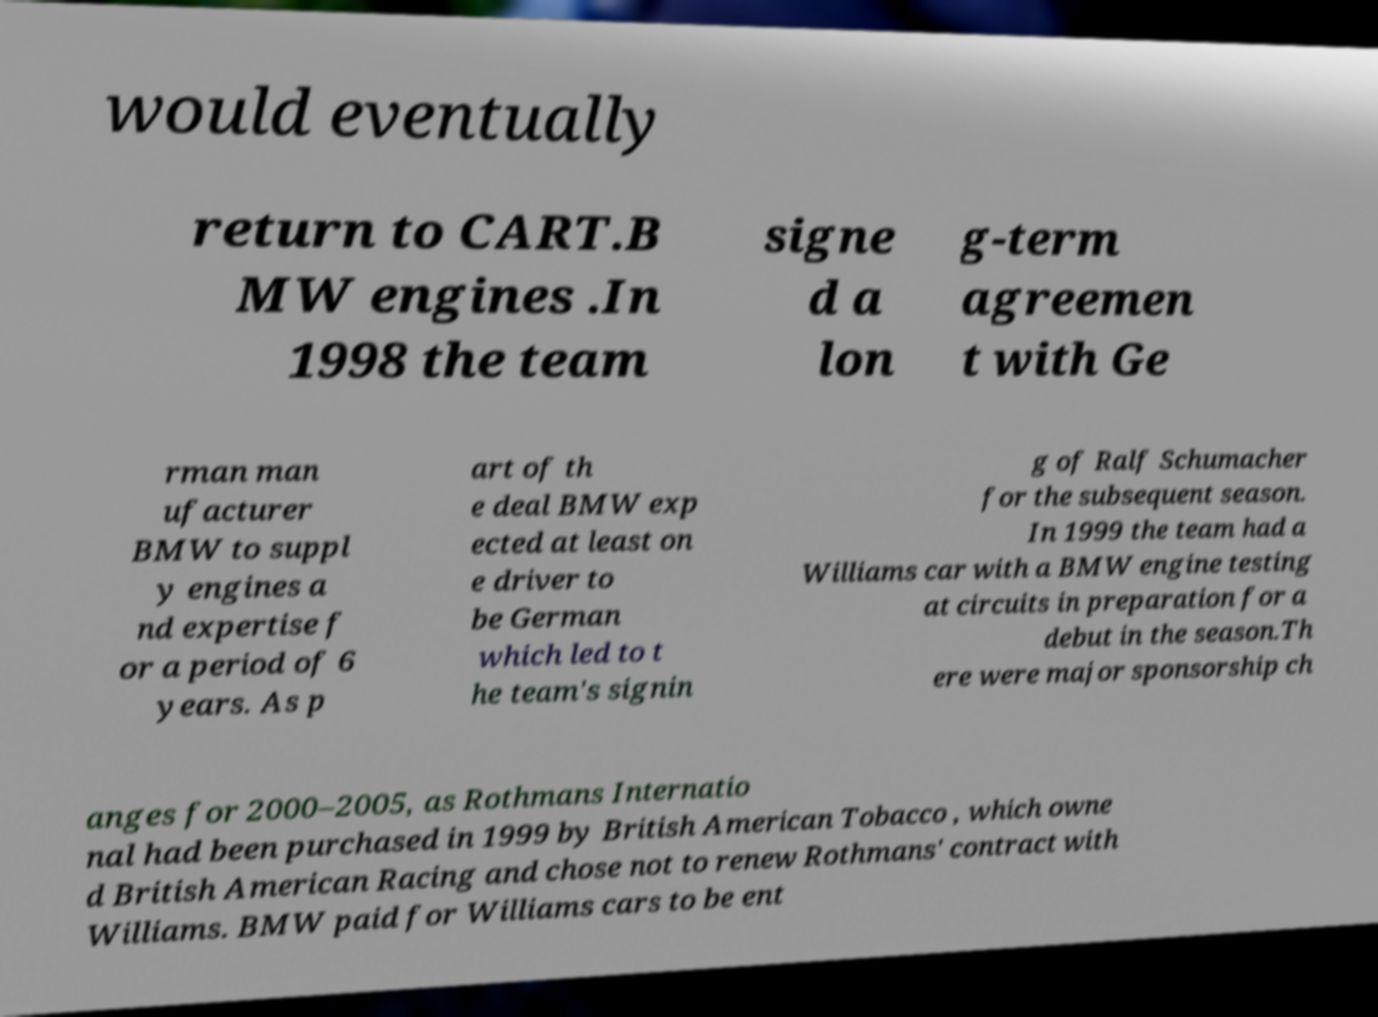Could you assist in decoding the text presented in this image and type it out clearly? would eventually return to CART.B MW engines .In 1998 the team signe d a lon g-term agreemen t with Ge rman man ufacturer BMW to suppl y engines a nd expertise f or a period of 6 years. As p art of th e deal BMW exp ected at least on e driver to be German which led to t he team's signin g of Ralf Schumacher for the subsequent season. In 1999 the team had a Williams car with a BMW engine testing at circuits in preparation for a debut in the season.Th ere were major sponsorship ch anges for 2000–2005, as Rothmans Internatio nal had been purchased in 1999 by British American Tobacco , which owne d British American Racing and chose not to renew Rothmans' contract with Williams. BMW paid for Williams cars to be ent 